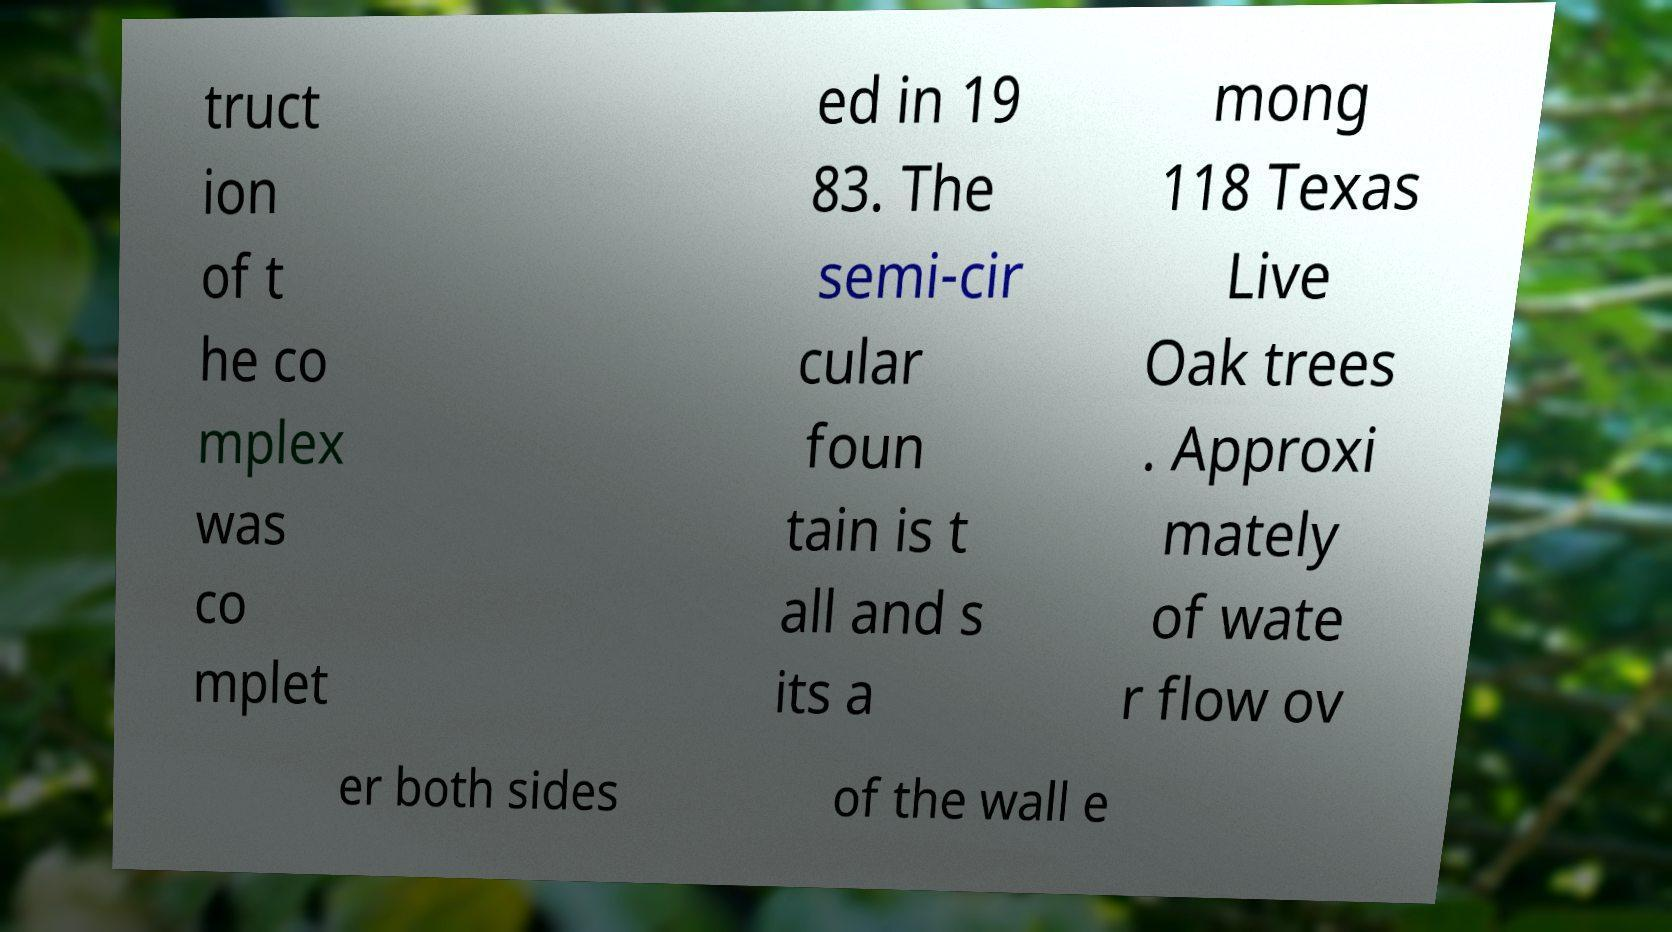Please read and relay the text visible in this image. What does it say? truct ion of t he co mplex was co mplet ed in 19 83. The semi-cir cular foun tain is t all and s its a mong 118 Texas Live Oak trees . Approxi mately of wate r flow ov er both sides of the wall e 